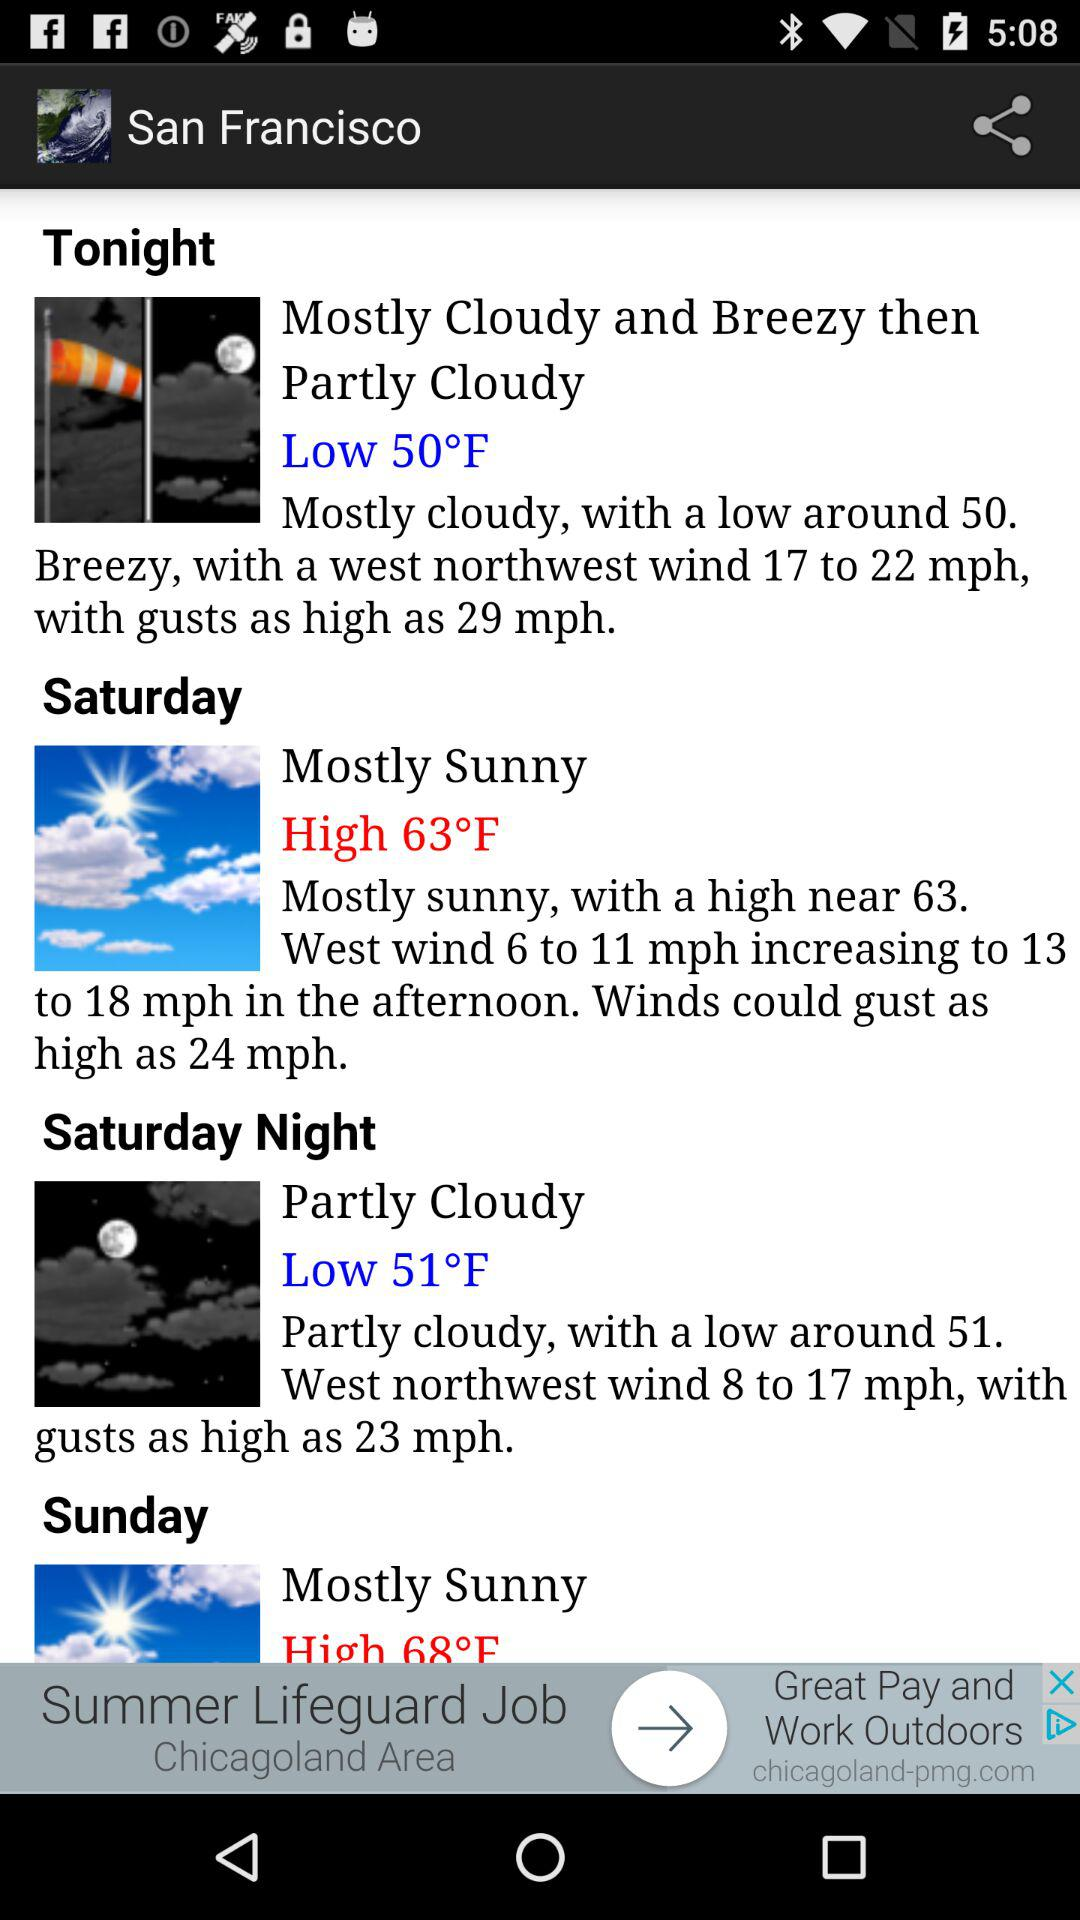For which city is the temperature shown on the screen? The temperature is shown for San Francisco. 